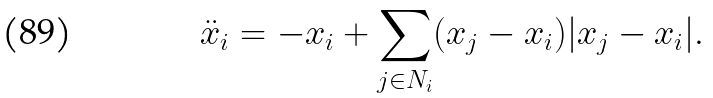Convert formula to latex. <formula><loc_0><loc_0><loc_500><loc_500>\ddot { x } _ { i } = - x _ { i } + \sum _ { j \in N _ { i } } ( x _ { j } - x _ { i } ) | x _ { j } - x _ { i } | .</formula> 